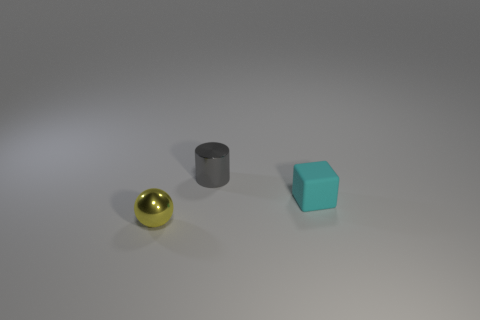Add 1 tiny red cylinders. How many objects exist? 4 Subtract all cylinders. How many objects are left? 2 Add 3 small rubber things. How many small rubber things exist? 4 Subtract 1 yellow spheres. How many objects are left? 2 Subtract all gray metallic cylinders. Subtract all cyan matte cubes. How many objects are left? 1 Add 1 small cyan matte things. How many small cyan matte things are left? 2 